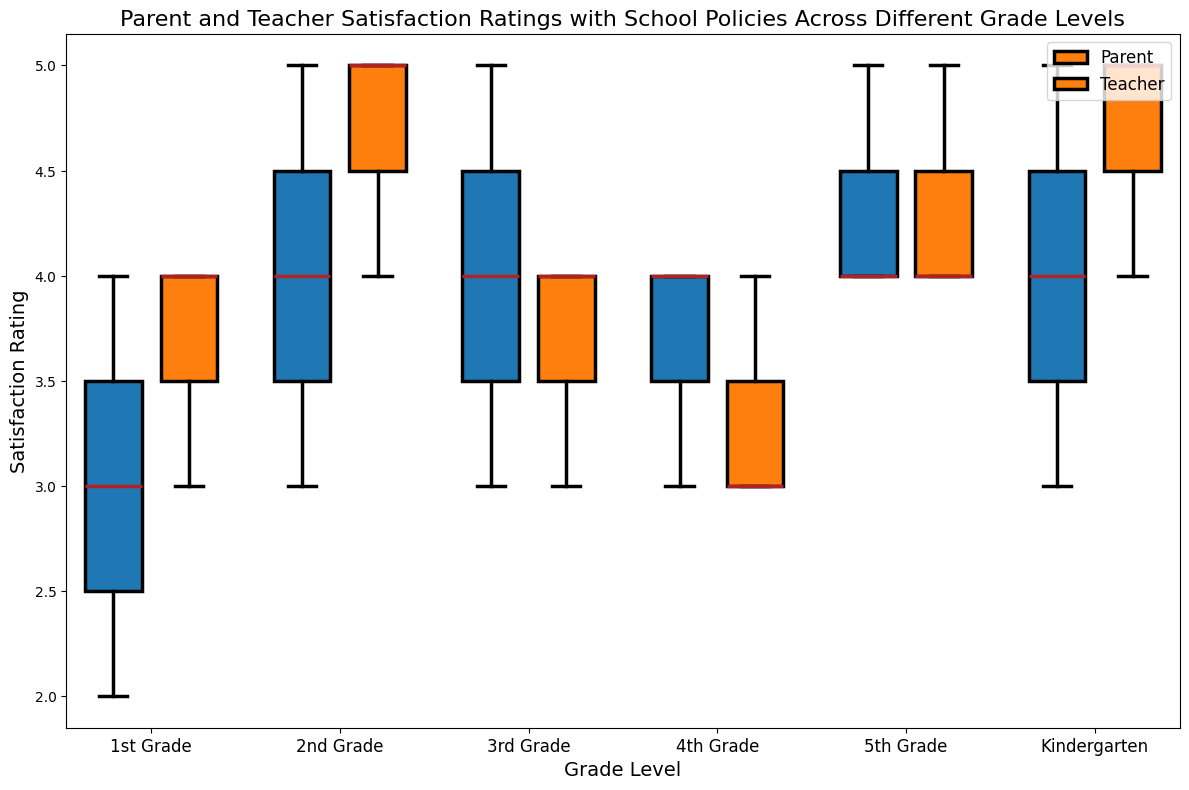What is the highest satisfaction rating given by parents in 2nd Grade? To find this, locate the box plot for 2nd Grade and focus on the parent's section. The highest point within the parent's box plot indicates the maximum rating.
Answer: 5 Compare the median satisfaction ratings of parents and teachers in 1st Grade. Which group has a higher median? Locate the median lines within the boxes for 1st Grade. The median for parents is represented as a line inside the parent's box plot section, and the median for teachers is within the teacher's box plot section. Compare the positions of the two lines.
Answer: Parents What is the range of teacher satisfaction ratings in 5th Grade? The range is the difference between the highest and lowest points (whiskers) in the teacher's box plot for 5th Grade. Find these points and subtract the lowest from the highest.
Answer: 1 (5 - 4) Compare the interquartile ranges (IQRs) of parent satisfaction ratings in Kindergarten and 3rd Grade. Which grade has a larger IQR? The IQR is the range between the first quartile (bottom of the box) and the third quartile (top of the box). Compare the heights of the boxes for parents in both Kindergarten and 3rd Grade. The larger box height indicates a larger IQR.
Answer: 3rd Grade In which grade level do teachers have the most consistent satisfaction ratings (i.e., smallest range)? Look at the length of the teacher's whiskers (range) in each grade level's box plot. The grade with the smallest whisker range represents the most consistent ratings.
Answer: 4th Grade What is the median satisfaction rating for Kindergarten teachers based on the box plot? Locate the box plot section for Kindergarten teachers and find the median line inside the box. The value at this line represents the median satisfaction rating.
Answer: 5 What is the average satisfaction rating given by parents in 1st Grade? Add all the ratings given by parents in 1st Grade and divide by the total number of ratings. Calculate (3+4+2)/3.
Answer: 3 Which grade level shows the biggest difference between teachers' and parents' median satisfaction ratings? Identify the median lines for both parents and teachers in each grade level box plot. Calculate the differences and determine which grade has the largest variance between these two medians.
Answer: Kindergarten (5 - 4) Are there any outliers in the satisfaction ratings for parents of 3rd Grade? Outliers are often shown as individual points distant from the whiskers or box. Observation of the box plot for 3rd Grade parents will indicate if any such points exist.
Answer: No How does the 4th Grade parent satisfaction rating interquartile range (IQR) compare to that of Kindergarten? Compare the height of the boxes representing the IQR for parents in both grade levels. The height of the box reflects the IQR size.
Answer: 4th Grade is smaller 